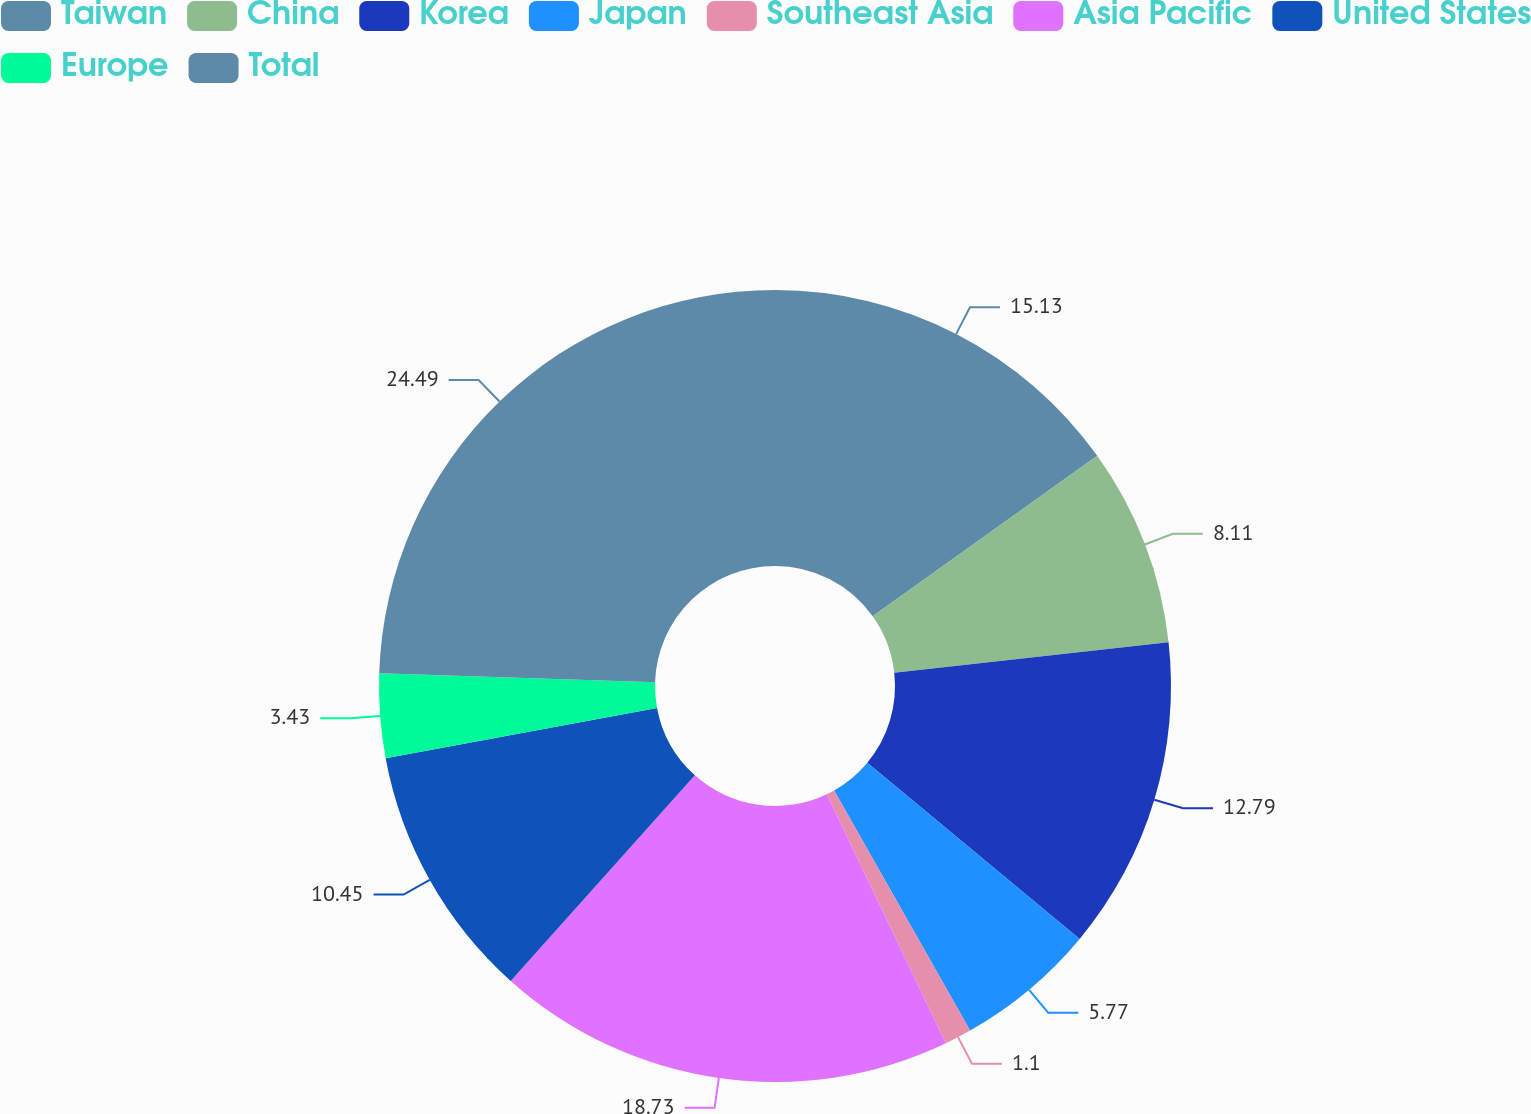Convert chart to OTSL. <chart><loc_0><loc_0><loc_500><loc_500><pie_chart><fcel>Taiwan<fcel>China<fcel>Korea<fcel>Japan<fcel>Southeast Asia<fcel>Asia Pacific<fcel>United States<fcel>Europe<fcel>Total<nl><fcel>15.13%<fcel>8.11%<fcel>12.79%<fcel>5.77%<fcel>1.1%<fcel>18.73%<fcel>10.45%<fcel>3.43%<fcel>24.49%<nl></chart> 